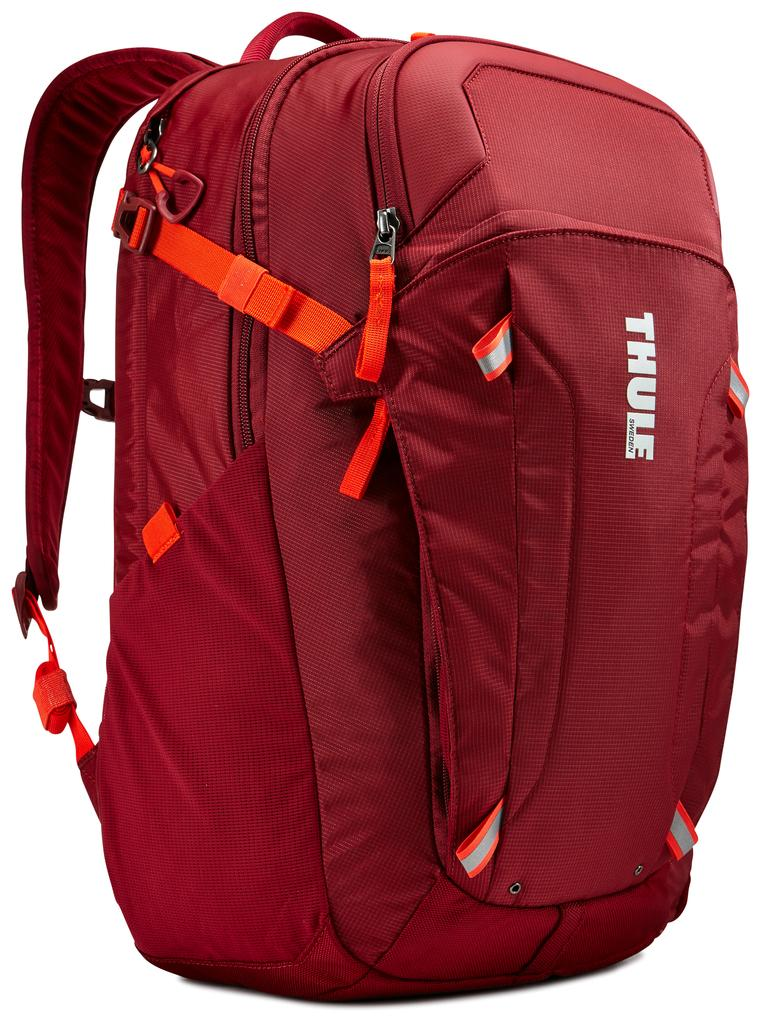What color is the backpack in the image? The backpack in the image is red. Are there any additional colors or patterns on the backpack? Yes, the backpack has an orange stripe. How many zips are on the backpack? The backpack has three zips. What type of boot can be seen inside the backpack in the image? There is no boot visible inside the backpack in the image. 